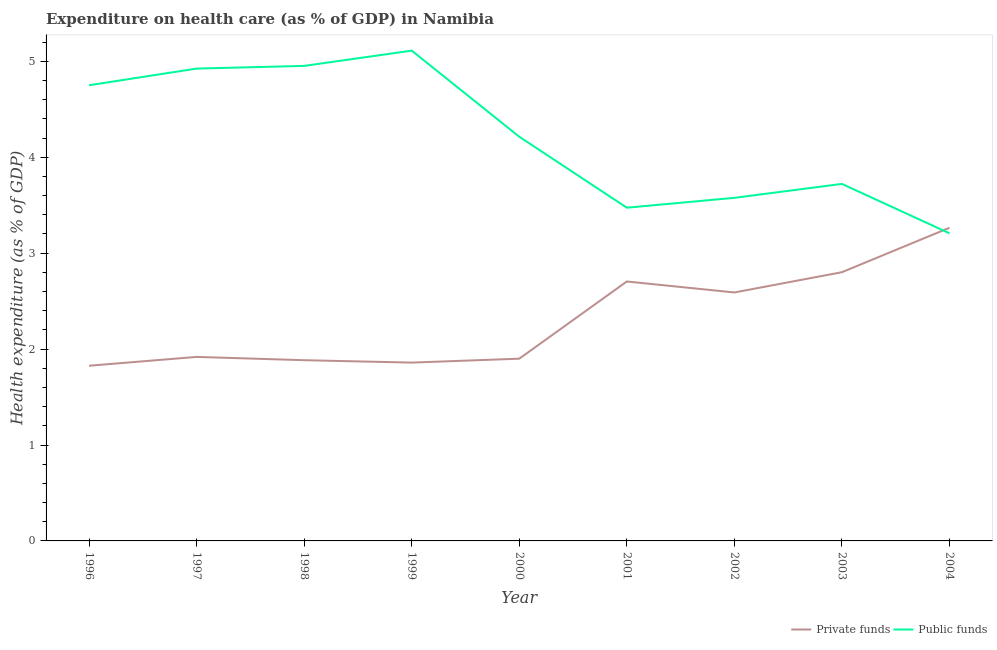Is the number of lines equal to the number of legend labels?
Provide a succinct answer. Yes. What is the amount of public funds spent in healthcare in 2000?
Keep it short and to the point. 4.21. Across all years, what is the maximum amount of public funds spent in healthcare?
Provide a short and direct response. 5.11. Across all years, what is the minimum amount of public funds spent in healthcare?
Provide a succinct answer. 3.21. In which year was the amount of public funds spent in healthcare maximum?
Give a very brief answer. 1999. In which year was the amount of private funds spent in healthcare minimum?
Your response must be concise. 1996. What is the total amount of public funds spent in healthcare in the graph?
Your answer should be very brief. 37.93. What is the difference between the amount of public funds spent in healthcare in 1999 and that in 2001?
Offer a terse response. 1.64. What is the difference between the amount of private funds spent in healthcare in 1999 and the amount of public funds spent in healthcare in 2001?
Ensure brevity in your answer.  -1.62. What is the average amount of private funds spent in healthcare per year?
Your answer should be very brief. 2.31. In the year 1996, what is the difference between the amount of public funds spent in healthcare and amount of private funds spent in healthcare?
Offer a very short reply. 2.92. In how many years, is the amount of private funds spent in healthcare greater than 3.2 %?
Provide a succinct answer. 1. What is the ratio of the amount of private funds spent in healthcare in 1997 to that in 2002?
Provide a short and direct response. 0.74. Is the difference between the amount of private funds spent in healthcare in 1996 and 2002 greater than the difference between the amount of public funds spent in healthcare in 1996 and 2002?
Your response must be concise. No. What is the difference between the highest and the second highest amount of private funds spent in healthcare?
Offer a very short reply. 0.46. What is the difference between the highest and the lowest amount of private funds spent in healthcare?
Ensure brevity in your answer.  1.44. Are the values on the major ticks of Y-axis written in scientific E-notation?
Offer a terse response. No. Does the graph contain grids?
Ensure brevity in your answer.  No. How are the legend labels stacked?
Keep it short and to the point. Horizontal. What is the title of the graph?
Give a very brief answer. Expenditure on health care (as % of GDP) in Namibia. Does "Techinal cooperation" appear as one of the legend labels in the graph?
Keep it short and to the point. No. What is the label or title of the X-axis?
Offer a very short reply. Year. What is the label or title of the Y-axis?
Offer a very short reply. Health expenditure (as % of GDP). What is the Health expenditure (as % of GDP) of Private funds in 1996?
Make the answer very short. 1.83. What is the Health expenditure (as % of GDP) of Public funds in 1996?
Your answer should be compact. 4.75. What is the Health expenditure (as % of GDP) in Private funds in 1997?
Keep it short and to the point. 1.92. What is the Health expenditure (as % of GDP) in Public funds in 1997?
Offer a terse response. 4.92. What is the Health expenditure (as % of GDP) of Private funds in 1998?
Make the answer very short. 1.88. What is the Health expenditure (as % of GDP) of Public funds in 1998?
Give a very brief answer. 4.95. What is the Health expenditure (as % of GDP) of Private funds in 1999?
Give a very brief answer. 1.86. What is the Health expenditure (as % of GDP) in Public funds in 1999?
Provide a succinct answer. 5.11. What is the Health expenditure (as % of GDP) in Private funds in 2000?
Provide a short and direct response. 1.9. What is the Health expenditure (as % of GDP) of Public funds in 2000?
Provide a succinct answer. 4.21. What is the Health expenditure (as % of GDP) of Private funds in 2001?
Offer a terse response. 2.7. What is the Health expenditure (as % of GDP) of Public funds in 2001?
Offer a very short reply. 3.47. What is the Health expenditure (as % of GDP) in Private funds in 2002?
Offer a terse response. 2.59. What is the Health expenditure (as % of GDP) in Public funds in 2002?
Your answer should be compact. 3.58. What is the Health expenditure (as % of GDP) in Private funds in 2003?
Keep it short and to the point. 2.8. What is the Health expenditure (as % of GDP) of Public funds in 2003?
Offer a very short reply. 3.72. What is the Health expenditure (as % of GDP) in Private funds in 2004?
Your answer should be compact. 3.26. What is the Health expenditure (as % of GDP) of Public funds in 2004?
Provide a short and direct response. 3.21. Across all years, what is the maximum Health expenditure (as % of GDP) of Private funds?
Your answer should be compact. 3.26. Across all years, what is the maximum Health expenditure (as % of GDP) of Public funds?
Your answer should be compact. 5.11. Across all years, what is the minimum Health expenditure (as % of GDP) in Private funds?
Offer a terse response. 1.83. Across all years, what is the minimum Health expenditure (as % of GDP) of Public funds?
Offer a terse response. 3.21. What is the total Health expenditure (as % of GDP) of Private funds in the graph?
Make the answer very short. 20.75. What is the total Health expenditure (as % of GDP) of Public funds in the graph?
Provide a succinct answer. 37.93. What is the difference between the Health expenditure (as % of GDP) in Private funds in 1996 and that in 1997?
Give a very brief answer. -0.09. What is the difference between the Health expenditure (as % of GDP) of Public funds in 1996 and that in 1997?
Your answer should be compact. -0.17. What is the difference between the Health expenditure (as % of GDP) in Private funds in 1996 and that in 1998?
Your response must be concise. -0.06. What is the difference between the Health expenditure (as % of GDP) of Public funds in 1996 and that in 1998?
Keep it short and to the point. -0.2. What is the difference between the Health expenditure (as % of GDP) of Private funds in 1996 and that in 1999?
Your answer should be very brief. -0.03. What is the difference between the Health expenditure (as % of GDP) of Public funds in 1996 and that in 1999?
Provide a short and direct response. -0.36. What is the difference between the Health expenditure (as % of GDP) of Private funds in 1996 and that in 2000?
Your answer should be very brief. -0.07. What is the difference between the Health expenditure (as % of GDP) in Public funds in 1996 and that in 2000?
Provide a succinct answer. 0.54. What is the difference between the Health expenditure (as % of GDP) of Private funds in 1996 and that in 2001?
Offer a very short reply. -0.88. What is the difference between the Health expenditure (as % of GDP) of Public funds in 1996 and that in 2001?
Your response must be concise. 1.28. What is the difference between the Health expenditure (as % of GDP) of Private funds in 1996 and that in 2002?
Make the answer very short. -0.76. What is the difference between the Health expenditure (as % of GDP) of Public funds in 1996 and that in 2002?
Keep it short and to the point. 1.17. What is the difference between the Health expenditure (as % of GDP) of Private funds in 1996 and that in 2003?
Offer a terse response. -0.98. What is the difference between the Health expenditure (as % of GDP) in Public funds in 1996 and that in 2003?
Your response must be concise. 1.03. What is the difference between the Health expenditure (as % of GDP) in Private funds in 1996 and that in 2004?
Keep it short and to the point. -1.44. What is the difference between the Health expenditure (as % of GDP) in Public funds in 1996 and that in 2004?
Your answer should be very brief. 1.54. What is the difference between the Health expenditure (as % of GDP) of Private funds in 1997 and that in 1998?
Your answer should be compact. 0.03. What is the difference between the Health expenditure (as % of GDP) of Public funds in 1997 and that in 1998?
Your response must be concise. -0.03. What is the difference between the Health expenditure (as % of GDP) in Private funds in 1997 and that in 1999?
Make the answer very short. 0.06. What is the difference between the Health expenditure (as % of GDP) in Public funds in 1997 and that in 1999?
Give a very brief answer. -0.19. What is the difference between the Health expenditure (as % of GDP) in Private funds in 1997 and that in 2000?
Keep it short and to the point. 0.02. What is the difference between the Health expenditure (as % of GDP) in Public funds in 1997 and that in 2000?
Your answer should be very brief. 0.71. What is the difference between the Health expenditure (as % of GDP) in Private funds in 1997 and that in 2001?
Your answer should be very brief. -0.79. What is the difference between the Health expenditure (as % of GDP) of Public funds in 1997 and that in 2001?
Your answer should be very brief. 1.45. What is the difference between the Health expenditure (as % of GDP) of Private funds in 1997 and that in 2002?
Keep it short and to the point. -0.67. What is the difference between the Health expenditure (as % of GDP) of Public funds in 1997 and that in 2002?
Your answer should be compact. 1.35. What is the difference between the Health expenditure (as % of GDP) of Private funds in 1997 and that in 2003?
Offer a very short reply. -0.88. What is the difference between the Health expenditure (as % of GDP) in Public funds in 1997 and that in 2003?
Your answer should be very brief. 1.2. What is the difference between the Health expenditure (as % of GDP) of Private funds in 1997 and that in 2004?
Keep it short and to the point. -1.35. What is the difference between the Health expenditure (as % of GDP) in Public funds in 1997 and that in 2004?
Make the answer very short. 1.72. What is the difference between the Health expenditure (as % of GDP) of Private funds in 1998 and that in 1999?
Your answer should be compact. 0.03. What is the difference between the Health expenditure (as % of GDP) in Public funds in 1998 and that in 1999?
Provide a succinct answer. -0.16. What is the difference between the Health expenditure (as % of GDP) in Private funds in 1998 and that in 2000?
Your answer should be very brief. -0.02. What is the difference between the Health expenditure (as % of GDP) of Public funds in 1998 and that in 2000?
Your response must be concise. 0.74. What is the difference between the Health expenditure (as % of GDP) in Private funds in 1998 and that in 2001?
Make the answer very short. -0.82. What is the difference between the Health expenditure (as % of GDP) of Public funds in 1998 and that in 2001?
Your response must be concise. 1.48. What is the difference between the Health expenditure (as % of GDP) of Private funds in 1998 and that in 2002?
Your response must be concise. -0.71. What is the difference between the Health expenditure (as % of GDP) in Public funds in 1998 and that in 2002?
Your response must be concise. 1.38. What is the difference between the Health expenditure (as % of GDP) of Private funds in 1998 and that in 2003?
Give a very brief answer. -0.92. What is the difference between the Health expenditure (as % of GDP) in Public funds in 1998 and that in 2003?
Your answer should be compact. 1.23. What is the difference between the Health expenditure (as % of GDP) of Private funds in 1998 and that in 2004?
Give a very brief answer. -1.38. What is the difference between the Health expenditure (as % of GDP) of Public funds in 1998 and that in 2004?
Offer a very short reply. 1.75. What is the difference between the Health expenditure (as % of GDP) in Private funds in 1999 and that in 2000?
Give a very brief answer. -0.04. What is the difference between the Health expenditure (as % of GDP) of Public funds in 1999 and that in 2000?
Provide a short and direct response. 0.9. What is the difference between the Health expenditure (as % of GDP) in Private funds in 1999 and that in 2001?
Provide a short and direct response. -0.85. What is the difference between the Health expenditure (as % of GDP) in Public funds in 1999 and that in 2001?
Offer a very short reply. 1.64. What is the difference between the Health expenditure (as % of GDP) of Private funds in 1999 and that in 2002?
Provide a succinct answer. -0.73. What is the difference between the Health expenditure (as % of GDP) in Public funds in 1999 and that in 2002?
Offer a very short reply. 1.53. What is the difference between the Health expenditure (as % of GDP) in Private funds in 1999 and that in 2003?
Give a very brief answer. -0.94. What is the difference between the Health expenditure (as % of GDP) in Public funds in 1999 and that in 2003?
Make the answer very short. 1.39. What is the difference between the Health expenditure (as % of GDP) of Private funds in 1999 and that in 2004?
Offer a very short reply. -1.41. What is the difference between the Health expenditure (as % of GDP) in Public funds in 1999 and that in 2004?
Offer a terse response. 1.9. What is the difference between the Health expenditure (as % of GDP) of Private funds in 2000 and that in 2001?
Offer a very short reply. -0.8. What is the difference between the Health expenditure (as % of GDP) in Public funds in 2000 and that in 2001?
Make the answer very short. 0.74. What is the difference between the Health expenditure (as % of GDP) in Private funds in 2000 and that in 2002?
Ensure brevity in your answer.  -0.69. What is the difference between the Health expenditure (as % of GDP) of Public funds in 2000 and that in 2002?
Provide a succinct answer. 0.64. What is the difference between the Health expenditure (as % of GDP) of Private funds in 2000 and that in 2003?
Your answer should be compact. -0.9. What is the difference between the Health expenditure (as % of GDP) of Public funds in 2000 and that in 2003?
Your response must be concise. 0.49. What is the difference between the Health expenditure (as % of GDP) of Private funds in 2000 and that in 2004?
Ensure brevity in your answer.  -1.36. What is the difference between the Health expenditure (as % of GDP) of Private funds in 2001 and that in 2002?
Your response must be concise. 0.11. What is the difference between the Health expenditure (as % of GDP) of Public funds in 2001 and that in 2002?
Your answer should be very brief. -0.1. What is the difference between the Health expenditure (as % of GDP) of Private funds in 2001 and that in 2003?
Provide a short and direct response. -0.1. What is the difference between the Health expenditure (as % of GDP) in Public funds in 2001 and that in 2003?
Offer a terse response. -0.25. What is the difference between the Health expenditure (as % of GDP) of Private funds in 2001 and that in 2004?
Give a very brief answer. -0.56. What is the difference between the Health expenditure (as % of GDP) in Public funds in 2001 and that in 2004?
Make the answer very short. 0.27. What is the difference between the Health expenditure (as % of GDP) in Private funds in 2002 and that in 2003?
Ensure brevity in your answer.  -0.21. What is the difference between the Health expenditure (as % of GDP) in Public funds in 2002 and that in 2003?
Your response must be concise. -0.15. What is the difference between the Health expenditure (as % of GDP) of Private funds in 2002 and that in 2004?
Offer a terse response. -0.67. What is the difference between the Health expenditure (as % of GDP) of Public funds in 2002 and that in 2004?
Ensure brevity in your answer.  0.37. What is the difference between the Health expenditure (as % of GDP) of Private funds in 2003 and that in 2004?
Make the answer very short. -0.46. What is the difference between the Health expenditure (as % of GDP) in Public funds in 2003 and that in 2004?
Ensure brevity in your answer.  0.52. What is the difference between the Health expenditure (as % of GDP) of Private funds in 1996 and the Health expenditure (as % of GDP) of Public funds in 1997?
Provide a short and direct response. -3.1. What is the difference between the Health expenditure (as % of GDP) of Private funds in 1996 and the Health expenditure (as % of GDP) of Public funds in 1998?
Give a very brief answer. -3.13. What is the difference between the Health expenditure (as % of GDP) of Private funds in 1996 and the Health expenditure (as % of GDP) of Public funds in 1999?
Give a very brief answer. -3.29. What is the difference between the Health expenditure (as % of GDP) in Private funds in 1996 and the Health expenditure (as % of GDP) in Public funds in 2000?
Your answer should be compact. -2.39. What is the difference between the Health expenditure (as % of GDP) of Private funds in 1996 and the Health expenditure (as % of GDP) of Public funds in 2001?
Provide a short and direct response. -1.65. What is the difference between the Health expenditure (as % of GDP) of Private funds in 1996 and the Health expenditure (as % of GDP) of Public funds in 2002?
Give a very brief answer. -1.75. What is the difference between the Health expenditure (as % of GDP) of Private funds in 1996 and the Health expenditure (as % of GDP) of Public funds in 2003?
Provide a succinct answer. -1.9. What is the difference between the Health expenditure (as % of GDP) of Private funds in 1996 and the Health expenditure (as % of GDP) of Public funds in 2004?
Your answer should be very brief. -1.38. What is the difference between the Health expenditure (as % of GDP) in Private funds in 1997 and the Health expenditure (as % of GDP) in Public funds in 1998?
Ensure brevity in your answer.  -3.03. What is the difference between the Health expenditure (as % of GDP) of Private funds in 1997 and the Health expenditure (as % of GDP) of Public funds in 1999?
Give a very brief answer. -3.19. What is the difference between the Health expenditure (as % of GDP) in Private funds in 1997 and the Health expenditure (as % of GDP) in Public funds in 2000?
Offer a very short reply. -2.3. What is the difference between the Health expenditure (as % of GDP) in Private funds in 1997 and the Health expenditure (as % of GDP) in Public funds in 2001?
Provide a short and direct response. -1.56. What is the difference between the Health expenditure (as % of GDP) of Private funds in 1997 and the Health expenditure (as % of GDP) of Public funds in 2002?
Ensure brevity in your answer.  -1.66. What is the difference between the Health expenditure (as % of GDP) in Private funds in 1997 and the Health expenditure (as % of GDP) in Public funds in 2003?
Make the answer very short. -1.8. What is the difference between the Health expenditure (as % of GDP) in Private funds in 1997 and the Health expenditure (as % of GDP) in Public funds in 2004?
Your answer should be very brief. -1.29. What is the difference between the Health expenditure (as % of GDP) of Private funds in 1998 and the Health expenditure (as % of GDP) of Public funds in 1999?
Give a very brief answer. -3.23. What is the difference between the Health expenditure (as % of GDP) of Private funds in 1998 and the Health expenditure (as % of GDP) of Public funds in 2000?
Your response must be concise. -2.33. What is the difference between the Health expenditure (as % of GDP) in Private funds in 1998 and the Health expenditure (as % of GDP) in Public funds in 2001?
Your answer should be compact. -1.59. What is the difference between the Health expenditure (as % of GDP) in Private funds in 1998 and the Health expenditure (as % of GDP) in Public funds in 2002?
Give a very brief answer. -1.69. What is the difference between the Health expenditure (as % of GDP) in Private funds in 1998 and the Health expenditure (as % of GDP) in Public funds in 2003?
Provide a succinct answer. -1.84. What is the difference between the Health expenditure (as % of GDP) in Private funds in 1998 and the Health expenditure (as % of GDP) in Public funds in 2004?
Keep it short and to the point. -1.32. What is the difference between the Health expenditure (as % of GDP) in Private funds in 1999 and the Health expenditure (as % of GDP) in Public funds in 2000?
Ensure brevity in your answer.  -2.35. What is the difference between the Health expenditure (as % of GDP) in Private funds in 1999 and the Health expenditure (as % of GDP) in Public funds in 2001?
Ensure brevity in your answer.  -1.61. What is the difference between the Health expenditure (as % of GDP) in Private funds in 1999 and the Health expenditure (as % of GDP) in Public funds in 2002?
Your response must be concise. -1.72. What is the difference between the Health expenditure (as % of GDP) in Private funds in 1999 and the Health expenditure (as % of GDP) in Public funds in 2003?
Give a very brief answer. -1.86. What is the difference between the Health expenditure (as % of GDP) of Private funds in 1999 and the Health expenditure (as % of GDP) of Public funds in 2004?
Your answer should be compact. -1.35. What is the difference between the Health expenditure (as % of GDP) of Private funds in 2000 and the Health expenditure (as % of GDP) of Public funds in 2001?
Ensure brevity in your answer.  -1.57. What is the difference between the Health expenditure (as % of GDP) in Private funds in 2000 and the Health expenditure (as % of GDP) in Public funds in 2002?
Your answer should be very brief. -1.68. What is the difference between the Health expenditure (as % of GDP) of Private funds in 2000 and the Health expenditure (as % of GDP) of Public funds in 2003?
Ensure brevity in your answer.  -1.82. What is the difference between the Health expenditure (as % of GDP) in Private funds in 2000 and the Health expenditure (as % of GDP) in Public funds in 2004?
Offer a terse response. -1.31. What is the difference between the Health expenditure (as % of GDP) in Private funds in 2001 and the Health expenditure (as % of GDP) in Public funds in 2002?
Offer a very short reply. -0.87. What is the difference between the Health expenditure (as % of GDP) in Private funds in 2001 and the Health expenditure (as % of GDP) in Public funds in 2003?
Give a very brief answer. -1.02. What is the difference between the Health expenditure (as % of GDP) in Private funds in 2001 and the Health expenditure (as % of GDP) in Public funds in 2004?
Your response must be concise. -0.5. What is the difference between the Health expenditure (as % of GDP) of Private funds in 2002 and the Health expenditure (as % of GDP) of Public funds in 2003?
Your response must be concise. -1.13. What is the difference between the Health expenditure (as % of GDP) of Private funds in 2002 and the Health expenditure (as % of GDP) of Public funds in 2004?
Offer a very short reply. -0.62. What is the difference between the Health expenditure (as % of GDP) in Private funds in 2003 and the Health expenditure (as % of GDP) in Public funds in 2004?
Keep it short and to the point. -0.41. What is the average Health expenditure (as % of GDP) in Private funds per year?
Ensure brevity in your answer.  2.31. What is the average Health expenditure (as % of GDP) in Public funds per year?
Provide a short and direct response. 4.21. In the year 1996, what is the difference between the Health expenditure (as % of GDP) in Private funds and Health expenditure (as % of GDP) in Public funds?
Your answer should be very brief. -2.92. In the year 1997, what is the difference between the Health expenditure (as % of GDP) of Private funds and Health expenditure (as % of GDP) of Public funds?
Your response must be concise. -3.01. In the year 1998, what is the difference between the Health expenditure (as % of GDP) of Private funds and Health expenditure (as % of GDP) of Public funds?
Ensure brevity in your answer.  -3.07. In the year 1999, what is the difference between the Health expenditure (as % of GDP) of Private funds and Health expenditure (as % of GDP) of Public funds?
Your answer should be very brief. -3.25. In the year 2000, what is the difference between the Health expenditure (as % of GDP) in Private funds and Health expenditure (as % of GDP) in Public funds?
Give a very brief answer. -2.31. In the year 2001, what is the difference between the Health expenditure (as % of GDP) in Private funds and Health expenditure (as % of GDP) in Public funds?
Keep it short and to the point. -0.77. In the year 2002, what is the difference between the Health expenditure (as % of GDP) in Private funds and Health expenditure (as % of GDP) in Public funds?
Provide a succinct answer. -0.99. In the year 2003, what is the difference between the Health expenditure (as % of GDP) of Private funds and Health expenditure (as % of GDP) of Public funds?
Make the answer very short. -0.92. In the year 2004, what is the difference between the Health expenditure (as % of GDP) in Private funds and Health expenditure (as % of GDP) in Public funds?
Make the answer very short. 0.06. What is the ratio of the Health expenditure (as % of GDP) of Private funds in 1996 to that in 1997?
Keep it short and to the point. 0.95. What is the ratio of the Health expenditure (as % of GDP) of Public funds in 1996 to that in 1997?
Your answer should be very brief. 0.96. What is the ratio of the Health expenditure (as % of GDP) of Private funds in 1996 to that in 1998?
Ensure brevity in your answer.  0.97. What is the ratio of the Health expenditure (as % of GDP) in Public funds in 1996 to that in 1998?
Make the answer very short. 0.96. What is the ratio of the Health expenditure (as % of GDP) of Private funds in 1996 to that in 1999?
Offer a very short reply. 0.98. What is the ratio of the Health expenditure (as % of GDP) of Public funds in 1996 to that in 1999?
Offer a terse response. 0.93. What is the ratio of the Health expenditure (as % of GDP) in Private funds in 1996 to that in 2000?
Provide a short and direct response. 0.96. What is the ratio of the Health expenditure (as % of GDP) in Public funds in 1996 to that in 2000?
Make the answer very short. 1.13. What is the ratio of the Health expenditure (as % of GDP) of Private funds in 1996 to that in 2001?
Keep it short and to the point. 0.68. What is the ratio of the Health expenditure (as % of GDP) of Public funds in 1996 to that in 2001?
Keep it short and to the point. 1.37. What is the ratio of the Health expenditure (as % of GDP) of Private funds in 1996 to that in 2002?
Your response must be concise. 0.71. What is the ratio of the Health expenditure (as % of GDP) in Public funds in 1996 to that in 2002?
Ensure brevity in your answer.  1.33. What is the ratio of the Health expenditure (as % of GDP) in Private funds in 1996 to that in 2003?
Offer a terse response. 0.65. What is the ratio of the Health expenditure (as % of GDP) in Public funds in 1996 to that in 2003?
Offer a terse response. 1.28. What is the ratio of the Health expenditure (as % of GDP) in Private funds in 1996 to that in 2004?
Provide a short and direct response. 0.56. What is the ratio of the Health expenditure (as % of GDP) in Public funds in 1996 to that in 2004?
Keep it short and to the point. 1.48. What is the ratio of the Health expenditure (as % of GDP) of Private funds in 1997 to that in 1998?
Give a very brief answer. 1.02. What is the ratio of the Health expenditure (as % of GDP) of Private funds in 1997 to that in 1999?
Provide a short and direct response. 1.03. What is the ratio of the Health expenditure (as % of GDP) in Public funds in 1997 to that in 1999?
Provide a succinct answer. 0.96. What is the ratio of the Health expenditure (as % of GDP) in Private funds in 1997 to that in 2000?
Offer a very short reply. 1.01. What is the ratio of the Health expenditure (as % of GDP) in Public funds in 1997 to that in 2000?
Offer a terse response. 1.17. What is the ratio of the Health expenditure (as % of GDP) of Private funds in 1997 to that in 2001?
Ensure brevity in your answer.  0.71. What is the ratio of the Health expenditure (as % of GDP) of Public funds in 1997 to that in 2001?
Your answer should be very brief. 1.42. What is the ratio of the Health expenditure (as % of GDP) of Private funds in 1997 to that in 2002?
Your response must be concise. 0.74. What is the ratio of the Health expenditure (as % of GDP) in Public funds in 1997 to that in 2002?
Keep it short and to the point. 1.38. What is the ratio of the Health expenditure (as % of GDP) of Private funds in 1997 to that in 2003?
Your answer should be very brief. 0.68. What is the ratio of the Health expenditure (as % of GDP) of Public funds in 1997 to that in 2003?
Offer a very short reply. 1.32. What is the ratio of the Health expenditure (as % of GDP) in Private funds in 1997 to that in 2004?
Keep it short and to the point. 0.59. What is the ratio of the Health expenditure (as % of GDP) of Public funds in 1997 to that in 2004?
Your answer should be compact. 1.54. What is the ratio of the Health expenditure (as % of GDP) of Private funds in 1998 to that in 1999?
Give a very brief answer. 1.01. What is the ratio of the Health expenditure (as % of GDP) of Public funds in 1998 to that in 1999?
Your answer should be very brief. 0.97. What is the ratio of the Health expenditure (as % of GDP) of Public funds in 1998 to that in 2000?
Give a very brief answer. 1.18. What is the ratio of the Health expenditure (as % of GDP) in Private funds in 1998 to that in 2001?
Your answer should be compact. 0.7. What is the ratio of the Health expenditure (as % of GDP) in Public funds in 1998 to that in 2001?
Offer a very short reply. 1.43. What is the ratio of the Health expenditure (as % of GDP) of Private funds in 1998 to that in 2002?
Offer a very short reply. 0.73. What is the ratio of the Health expenditure (as % of GDP) of Public funds in 1998 to that in 2002?
Your answer should be very brief. 1.38. What is the ratio of the Health expenditure (as % of GDP) in Private funds in 1998 to that in 2003?
Your response must be concise. 0.67. What is the ratio of the Health expenditure (as % of GDP) in Public funds in 1998 to that in 2003?
Give a very brief answer. 1.33. What is the ratio of the Health expenditure (as % of GDP) in Private funds in 1998 to that in 2004?
Offer a terse response. 0.58. What is the ratio of the Health expenditure (as % of GDP) of Public funds in 1998 to that in 2004?
Your answer should be very brief. 1.54. What is the ratio of the Health expenditure (as % of GDP) in Private funds in 1999 to that in 2000?
Keep it short and to the point. 0.98. What is the ratio of the Health expenditure (as % of GDP) in Public funds in 1999 to that in 2000?
Your response must be concise. 1.21. What is the ratio of the Health expenditure (as % of GDP) in Private funds in 1999 to that in 2001?
Offer a very short reply. 0.69. What is the ratio of the Health expenditure (as % of GDP) of Public funds in 1999 to that in 2001?
Your answer should be very brief. 1.47. What is the ratio of the Health expenditure (as % of GDP) of Private funds in 1999 to that in 2002?
Provide a succinct answer. 0.72. What is the ratio of the Health expenditure (as % of GDP) of Public funds in 1999 to that in 2002?
Offer a very short reply. 1.43. What is the ratio of the Health expenditure (as % of GDP) of Private funds in 1999 to that in 2003?
Offer a very short reply. 0.66. What is the ratio of the Health expenditure (as % of GDP) of Public funds in 1999 to that in 2003?
Your response must be concise. 1.37. What is the ratio of the Health expenditure (as % of GDP) in Private funds in 1999 to that in 2004?
Offer a very short reply. 0.57. What is the ratio of the Health expenditure (as % of GDP) in Public funds in 1999 to that in 2004?
Provide a short and direct response. 1.59. What is the ratio of the Health expenditure (as % of GDP) in Private funds in 2000 to that in 2001?
Your response must be concise. 0.7. What is the ratio of the Health expenditure (as % of GDP) of Public funds in 2000 to that in 2001?
Offer a terse response. 1.21. What is the ratio of the Health expenditure (as % of GDP) in Private funds in 2000 to that in 2002?
Offer a terse response. 0.73. What is the ratio of the Health expenditure (as % of GDP) of Public funds in 2000 to that in 2002?
Offer a very short reply. 1.18. What is the ratio of the Health expenditure (as % of GDP) in Private funds in 2000 to that in 2003?
Provide a short and direct response. 0.68. What is the ratio of the Health expenditure (as % of GDP) of Public funds in 2000 to that in 2003?
Keep it short and to the point. 1.13. What is the ratio of the Health expenditure (as % of GDP) in Private funds in 2000 to that in 2004?
Your answer should be compact. 0.58. What is the ratio of the Health expenditure (as % of GDP) in Public funds in 2000 to that in 2004?
Provide a succinct answer. 1.31. What is the ratio of the Health expenditure (as % of GDP) in Private funds in 2001 to that in 2002?
Give a very brief answer. 1.04. What is the ratio of the Health expenditure (as % of GDP) of Public funds in 2001 to that in 2002?
Give a very brief answer. 0.97. What is the ratio of the Health expenditure (as % of GDP) in Private funds in 2001 to that in 2003?
Your response must be concise. 0.97. What is the ratio of the Health expenditure (as % of GDP) of Public funds in 2001 to that in 2003?
Give a very brief answer. 0.93. What is the ratio of the Health expenditure (as % of GDP) of Private funds in 2001 to that in 2004?
Your answer should be compact. 0.83. What is the ratio of the Health expenditure (as % of GDP) in Private funds in 2002 to that in 2003?
Provide a short and direct response. 0.92. What is the ratio of the Health expenditure (as % of GDP) in Public funds in 2002 to that in 2003?
Give a very brief answer. 0.96. What is the ratio of the Health expenditure (as % of GDP) in Private funds in 2002 to that in 2004?
Give a very brief answer. 0.79. What is the ratio of the Health expenditure (as % of GDP) of Public funds in 2002 to that in 2004?
Offer a very short reply. 1.12. What is the ratio of the Health expenditure (as % of GDP) in Private funds in 2003 to that in 2004?
Ensure brevity in your answer.  0.86. What is the ratio of the Health expenditure (as % of GDP) in Public funds in 2003 to that in 2004?
Give a very brief answer. 1.16. What is the difference between the highest and the second highest Health expenditure (as % of GDP) in Private funds?
Give a very brief answer. 0.46. What is the difference between the highest and the second highest Health expenditure (as % of GDP) in Public funds?
Your response must be concise. 0.16. What is the difference between the highest and the lowest Health expenditure (as % of GDP) in Private funds?
Offer a terse response. 1.44. What is the difference between the highest and the lowest Health expenditure (as % of GDP) of Public funds?
Give a very brief answer. 1.9. 